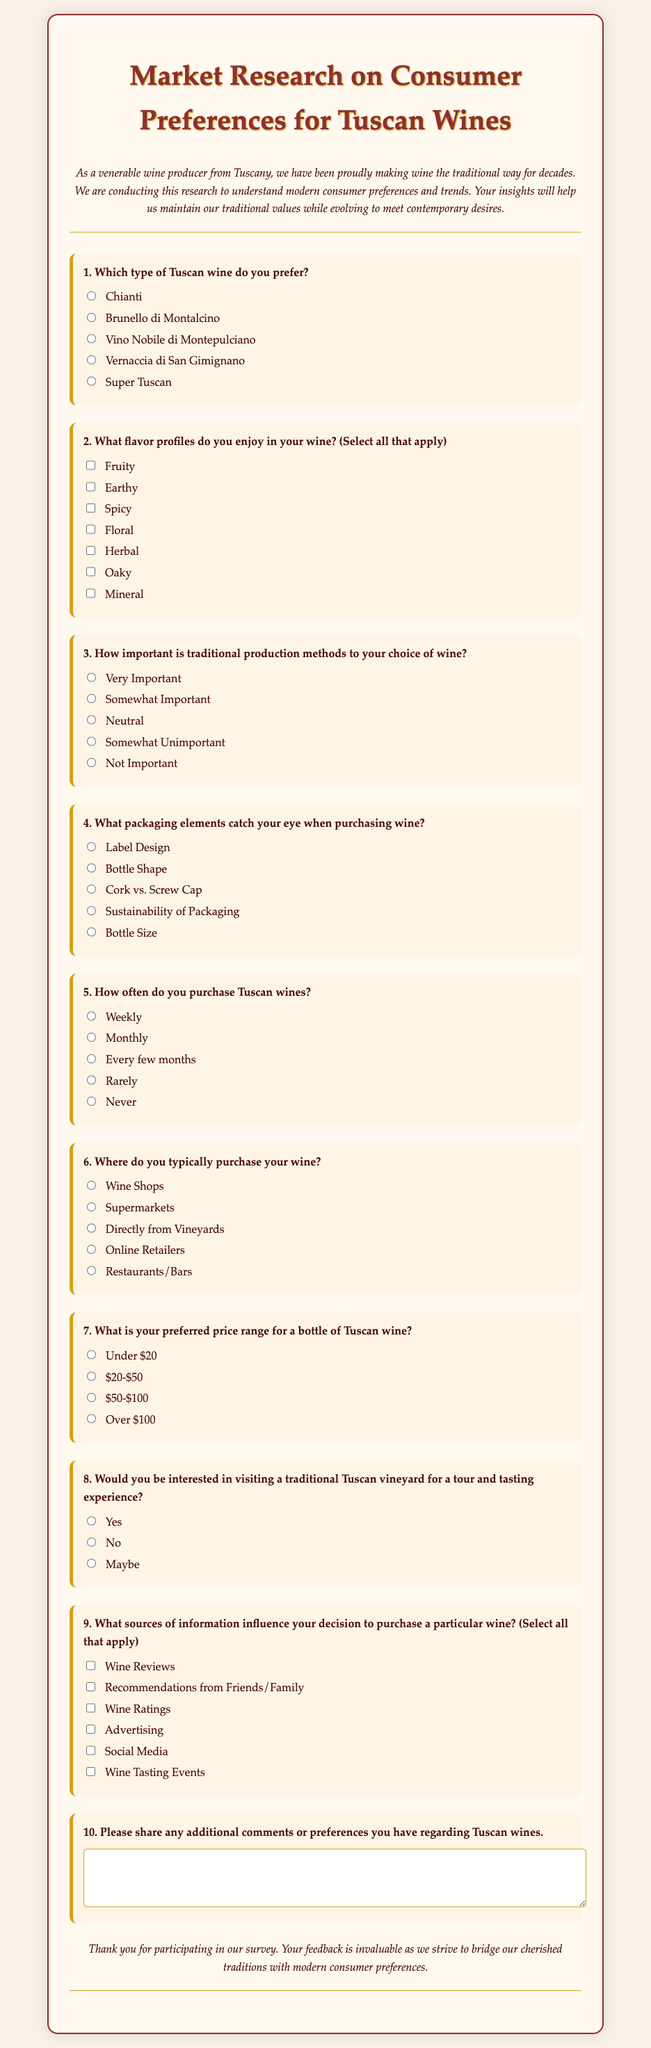What is the title of the questionnaire? The title is prominently displayed at the top of the document.
Answer: Market Research on Consumer Preferences for Tuscan Wines How many types of Tuscan wine can respondents choose from? The document lists a specific number of Tuscan wine types in the first question.
Answer: Five What flavor profile is not listed in the options? By reviewing the flavor profiles listed in the second question, we can determine what is missing.
Answer: Sweet How is the importance of traditional production methods categorized in the questionnaire? The third question provides a set of categories to choose from regarding the importance of traditional methods.
Answer: Very Important, Somewhat Important, Neutral, Somewhat Unimportant, Not Important What are the respondents asked about packaging elements in question 4? Question 4 specifically addresses which elements catch respondents’ eyes when purchasing wine.
Answer: Label Design, Bottle Shape, Cork vs. Screw Cap, Sustainability of Packaging, Bottle Size How often are respondents asked about their wine purchasing frequency? The fifth question directly inquires about the frequency of purchasing Tuscan wines.
Answer: Weekly, Monthly, Every few months, Rarely, Never What influences the decision to purchase a particular wine according to question 9? Question 9 lists various sources of information that may impact the purchasing choice.
Answer: Wine Reviews, Recommendations from Friends/Family, Wine Ratings, Advertising, Social Media, Wine Tasting Events What is the purpose of the questionnaire as stated in the introduction? The introduction explains the main aim for conducting the survey to gather insights.
Answer: Understanding modern consumer preferences and trends Which type of wine has no option for "Not Interested" in the vineyard visit question? Question 8 provides different options with no "Not Interested" response.
Answer: Yes, No, Maybe 